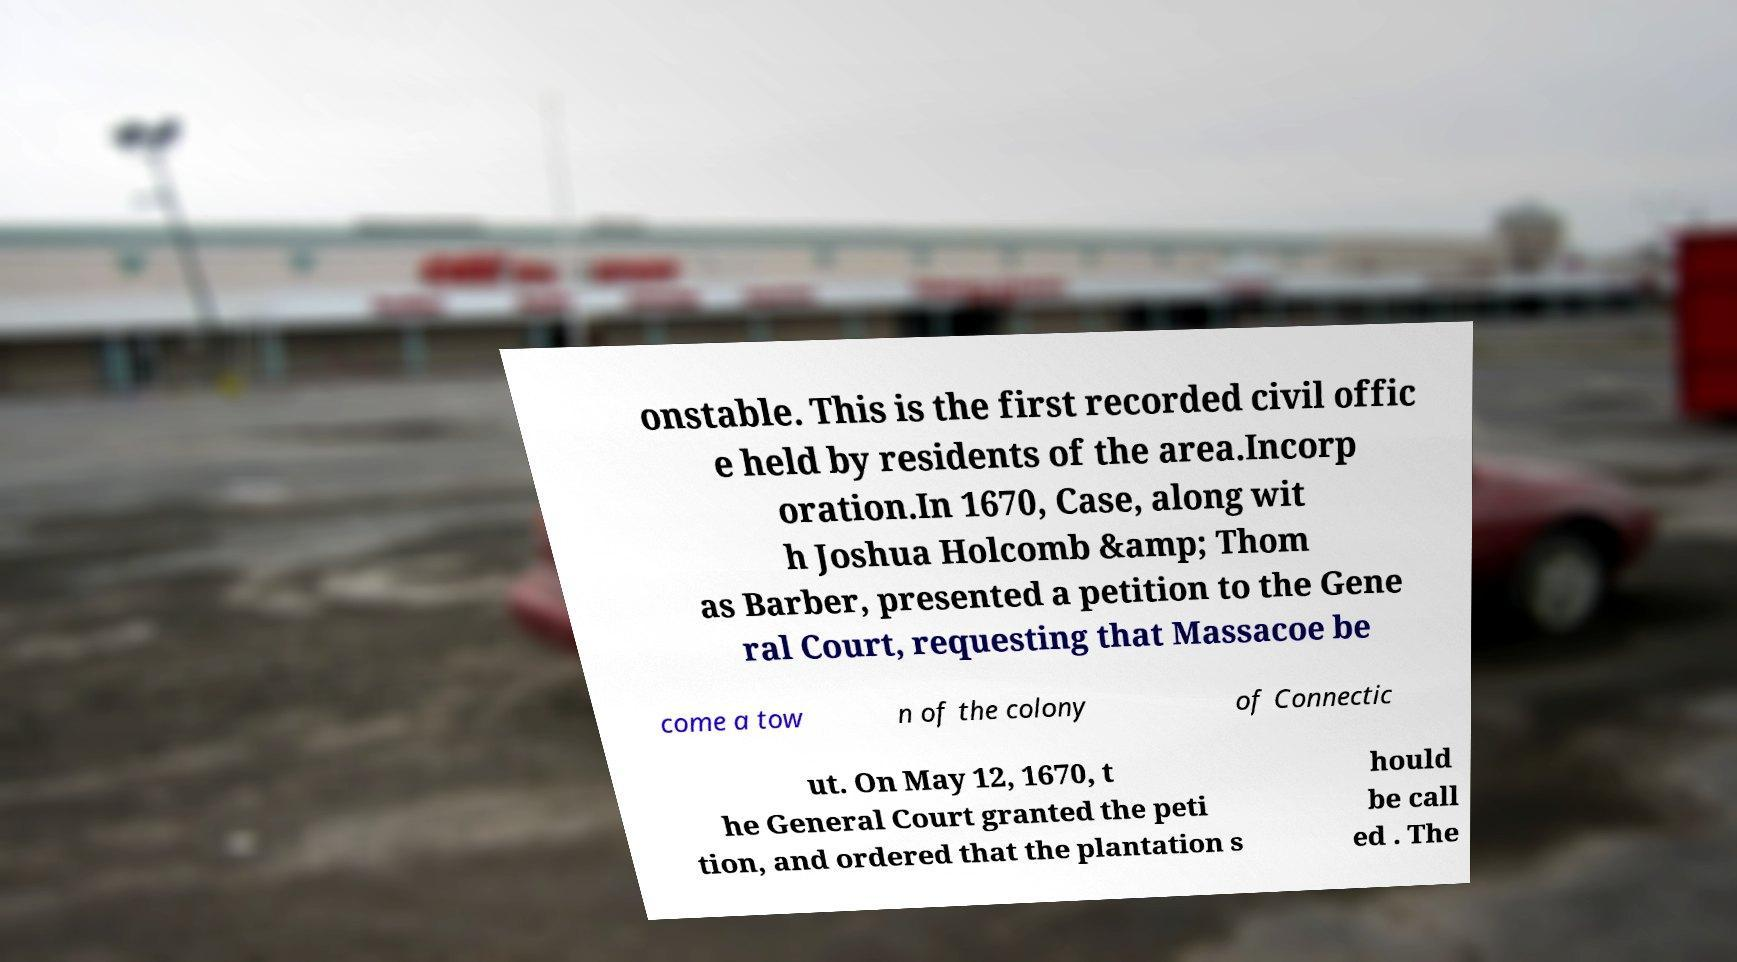Could you extract and type out the text from this image? onstable. This is the first recorded civil offic e held by residents of the area.Incorp oration.In 1670, Case, along wit h Joshua Holcomb &amp; Thom as Barber, presented a petition to the Gene ral Court, requesting that Massacoe be come a tow n of the colony of Connectic ut. On May 12, 1670, t he General Court granted the peti tion, and ordered that the plantation s hould be call ed . The 